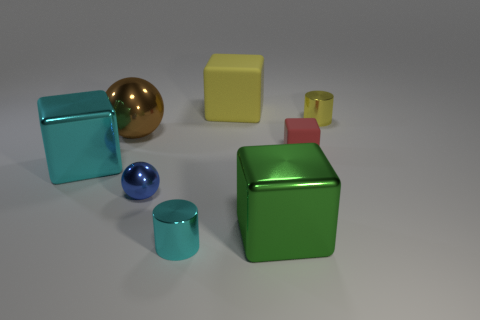The tiny yellow thing that is the same material as the blue sphere is what shape?
Ensure brevity in your answer.  Cylinder. Is the yellow cube the same size as the cyan cylinder?
Your answer should be very brief. No. Is the material of the big cube behind the tiny yellow object the same as the red thing?
Keep it short and to the point. Yes. There is a metal cylinder behind the cyan metal thing that is behind the green block; what number of tiny red things are in front of it?
Your answer should be compact. 1. There is a cyan metal object behind the green object; does it have the same shape as the red matte object?
Provide a succinct answer. Yes. What number of objects are either large brown matte cubes or blocks that are to the right of the large cyan metal object?
Your response must be concise. 3. Is the number of large green shiny objects that are behind the large rubber cube greater than the number of green metallic blocks?
Provide a short and direct response. No. Are there an equal number of green metal blocks that are left of the brown thing and large brown things on the right side of the tiny matte cube?
Ensure brevity in your answer.  Yes. There is a metallic cylinder to the left of the small rubber cube; are there any yellow blocks that are in front of it?
Your answer should be very brief. No. What shape is the large green metallic thing?
Keep it short and to the point. Cube. 